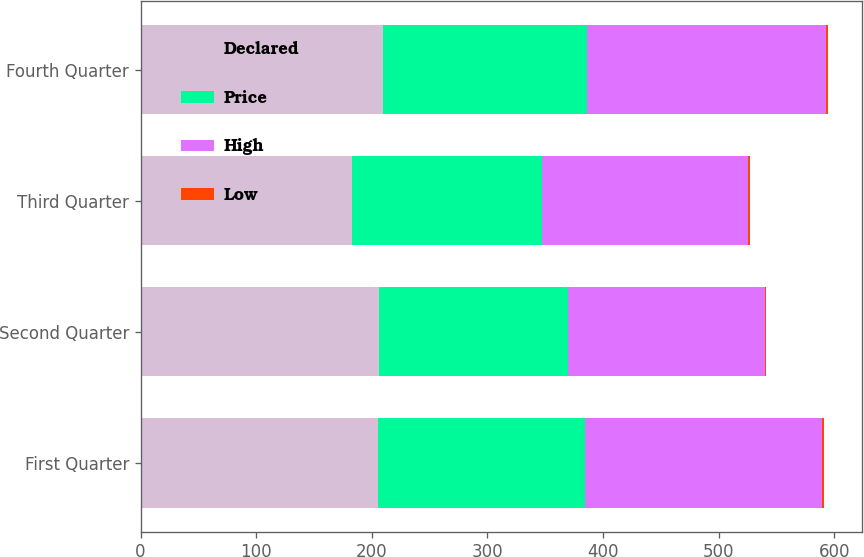<chart> <loc_0><loc_0><loc_500><loc_500><stacked_bar_chart><ecel><fcel>First Quarter<fcel>Second Quarter<fcel>Third Quarter<fcel>Fourth Quarter<nl><fcel>Declared<fcel>205.6<fcel>206.57<fcel>183<fcel>209.29<nl><fcel>Price<fcel>179.13<fcel>163.37<fcel>164.06<fcel>177.17<nl><fcel>High<fcel>204.9<fcel>169.82<fcel>178.3<fcel>206.71<nl><fcel>Low<fcel>1.5<fcel>1.5<fcel>1.5<fcel>1.5<nl></chart> 